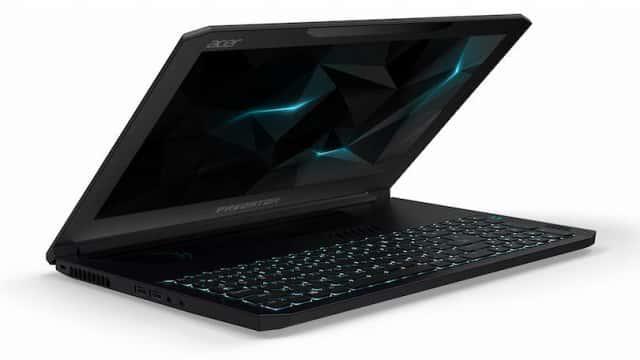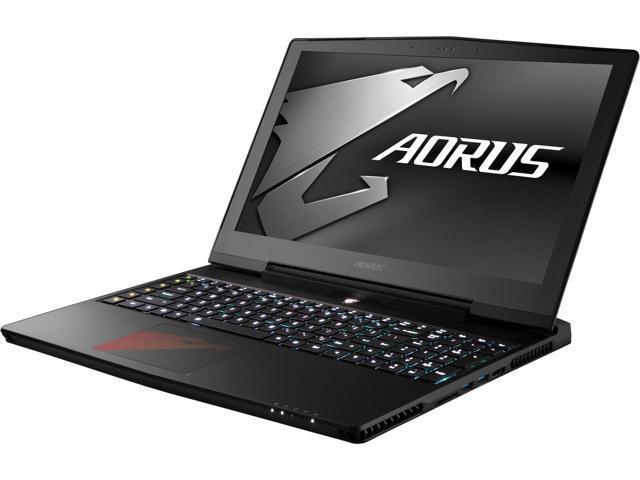The first image is the image on the left, the second image is the image on the right. Analyze the images presented: Is the assertion "The laptop on the right displays the tiles from the operating system Windows." valid? Answer yes or no. No. 